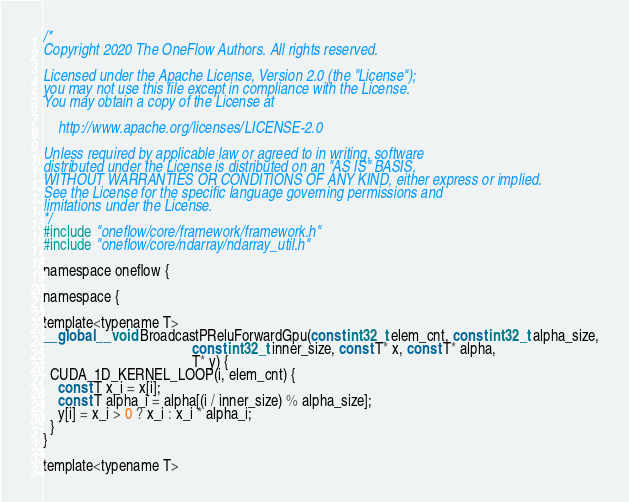Convert code to text. <code><loc_0><loc_0><loc_500><loc_500><_Cuda_>/*
Copyright 2020 The OneFlow Authors. All rights reserved.

Licensed under the Apache License, Version 2.0 (the "License");
you may not use this file except in compliance with the License.
You may obtain a copy of the License at

    http://www.apache.org/licenses/LICENSE-2.0

Unless required by applicable law or agreed to in writing, software
distributed under the License is distributed on an "AS IS" BASIS,
WITHOUT WARRANTIES OR CONDITIONS OF ANY KIND, either express or implied.
See the License for the specific language governing permissions and
limitations under the License.
*/
#include "oneflow/core/framework/framework.h"
#include "oneflow/core/ndarray/ndarray_util.h"

namespace oneflow {

namespace {

template<typename T>
__global__ void BroadcastPReluForwardGpu(const int32_t elem_cnt, const int32_t alpha_size,
                                         const int32_t inner_size, const T* x, const T* alpha,
                                         T* y) {
  CUDA_1D_KERNEL_LOOP(i, elem_cnt) {
    const T x_i = x[i];
    const T alpha_i = alpha[(i / inner_size) % alpha_size];
    y[i] = x_i > 0 ? x_i : x_i * alpha_i;
  }
}

template<typename T></code> 